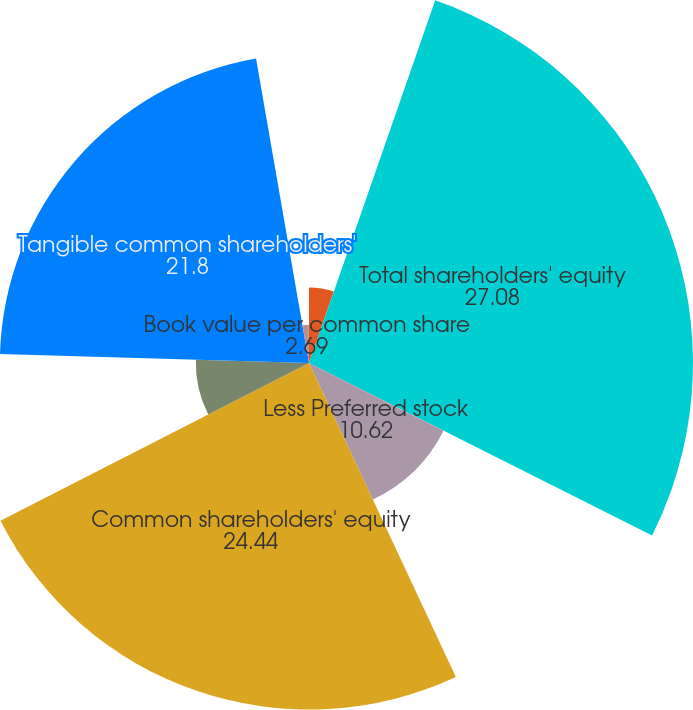Convert chart to OTSL. <chart><loc_0><loc_0><loc_500><loc_500><pie_chart><fcel>in millions except per share<fcel>Total shareholders' equity<fcel>Less Preferred stock<fcel>Common shareholders' equity<fcel>Less Goodwill and identifiable<fcel>Tangible common shareholders'<fcel>Book value per common share<fcel>Tangible book value per common<nl><fcel>5.33%<fcel>27.08%<fcel>10.62%<fcel>24.44%<fcel>7.98%<fcel>21.8%<fcel>2.69%<fcel>0.05%<nl></chart> 